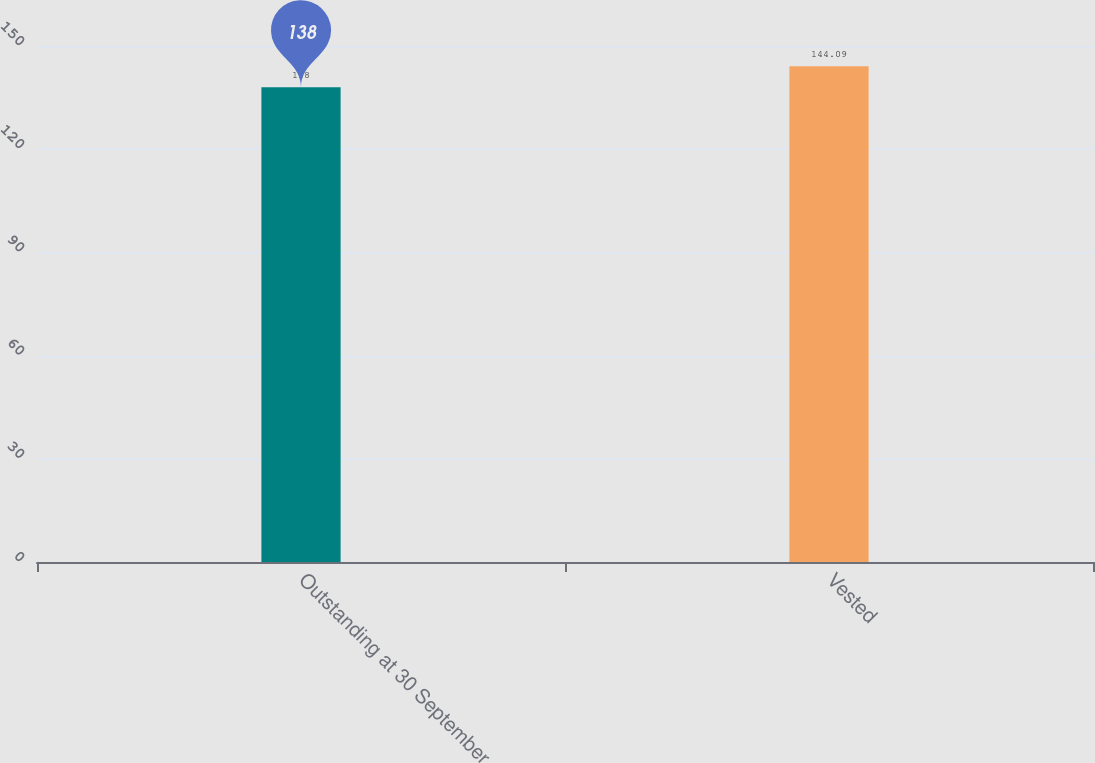Convert chart to OTSL. <chart><loc_0><loc_0><loc_500><loc_500><bar_chart><fcel>Outstanding at 30 September<fcel>Vested<nl><fcel>138<fcel>144.09<nl></chart> 